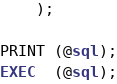<code> <loc_0><loc_0><loc_500><loc_500><_SQL_>	);

PRINT (@sql);
EXEC  (@sql);
</code> 